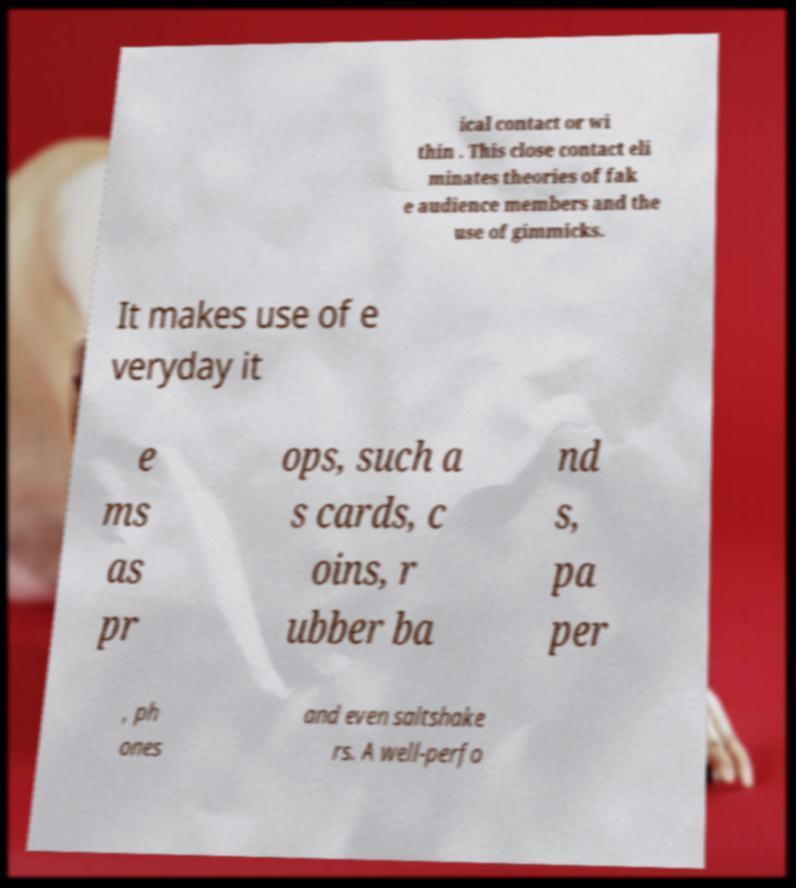Please read and relay the text visible in this image. What does it say? ical contact or wi thin . This close contact eli minates theories of fak e audience members and the use of gimmicks. It makes use of e veryday it e ms as pr ops, such a s cards, c oins, r ubber ba nd s, pa per , ph ones and even saltshake rs. A well-perfo 